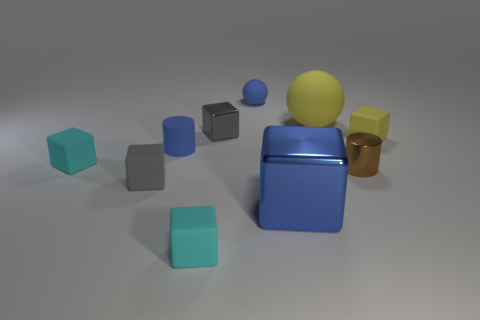There is a matte cube on the left side of the tiny gray thing on the left side of the gray metal cube; what color is it?
Provide a short and direct response. Cyan. There is a gray metallic object that is the same size as the yellow matte cube; what shape is it?
Ensure brevity in your answer.  Cube. There is a large thing that is the same color as the small sphere; what shape is it?
Ensure brevity in your answer.  Cube. Are there an equal number of small blue objects on the left side of the small metal cube and tiny gray metallic things?
Keep it short and to the point. Yes. What material is the cylinder that is behind the cyan matte object that is on the left side of the small blue cylinder that is in front of the blue sphere?
Your answer should be very brief. Rubber. There is a large thing that is the same material as the brown cylinder; what shape is it?
Provide a succinct answer. Cube. Is there any other thing that has the same color as the large shiny block?
Ensure brevity in your answer.  Yes. How many gray things are in front of the cylinder in front of the tiny cyan rubber cube that is behind the brown cylinder?
Provide a succinct answer. 1. What number of brown things are either tiny metal things or large matte spheres?
Provide a short and direct response. 1. There is a blue sphere; is it the same size as the gray object to the left of the tiny blue cylinder?
Provide a succinct answer. Yes. 